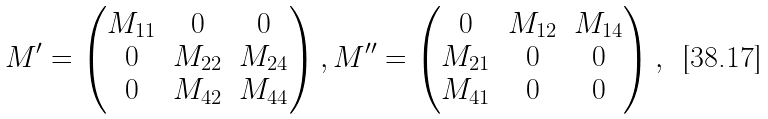<formula> <loc_0><loc_0><loc_500><loc_500>M ^ { \prime } = \begin{pmatrix} M _ { 1 1 } & 0 & 0 \\ 0 & M _ { 2 2 } & M _ { 2 4 } \\ 0 & M _ { 4 2 } & M _ { 4 4 } \end{pmatrix} , M ^ { \prime \prime } = \begin{pmatrix} 0 & M _ { 1 2 } & M _ { 1 4 } \\ M _ { 2 1 } & 0 & 0 \\ M _ { 4 1 } & 0 & 0 \end{pmatrix} ,</formula> 